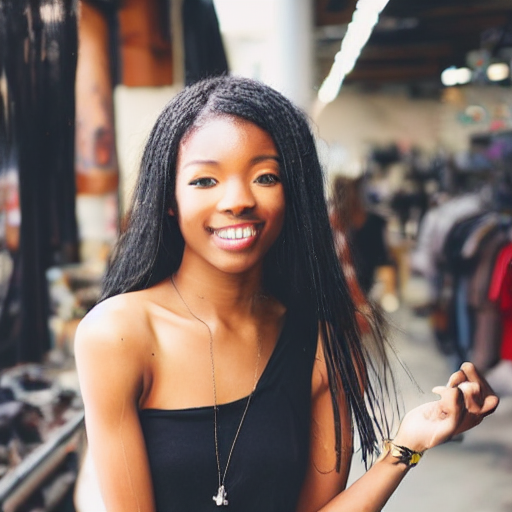What emotions or attitudes does the subject's pose and expression convey? Her pose and expression exude confidence and happiness. The way she stands with her body slightly angled towards the camera, her smile broad and genuine, and her eyes bright and inviting, all contribute to a portrayal of positivity and approachability. 